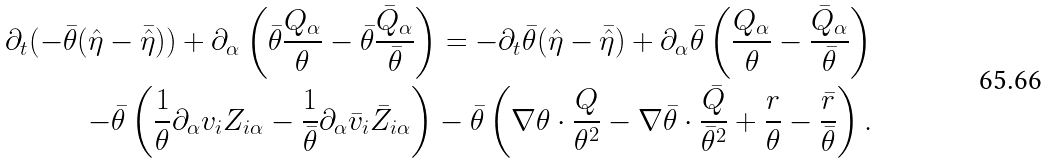Convert formula to latex. <formula><loc_0><loc_0><loc_500><loc_500>\partial _ { t } ( - \bar { \theta } ( \hat { \eta } - \bar { \hat { \eta } } ) ) + \partial _ { \alpha } \left ( \bar { \theta } \frac { Q _ { \alpha } } { \theta } - \bar { \theta } \frac { \bar { Q } _ { \alpha } } { \bar { \theta } } \right ) = - \partial _ { t } \bar { \theta } ( \hat { \eta } - \bar { \hat { \eta } } ) + \partial _ { \alpha } \bar { \theta } \left ( \frac { Q _ { \alpha } } { \theta } - \frac { \bar { Q } _ { \alpha } } { \bar { \theta } } \right ) \\ - \bar { \theta } \left ( \frac { 1 } { \theta } \partial _ { \alpha } v _ { i } Z _ { i \alpha } - \frac { 1 } { \bar { \theta } } \partial _ { \alpha } \bar { v } _ { i } \bar { Z } _ { i \alpha } \right ) - \bar { \theta } \left ( \nabla \theta \cdot \frac { Q } { \theta ^ { 2 } } - \nabla \bar { \theta } \cdot \frac { \bar { Q } } { \bar { \theta } ^ { 2 } } + \frac { r } { \theta } - \frac { \bar { r } } { \bar { \theta } } \right ) .</formula> 